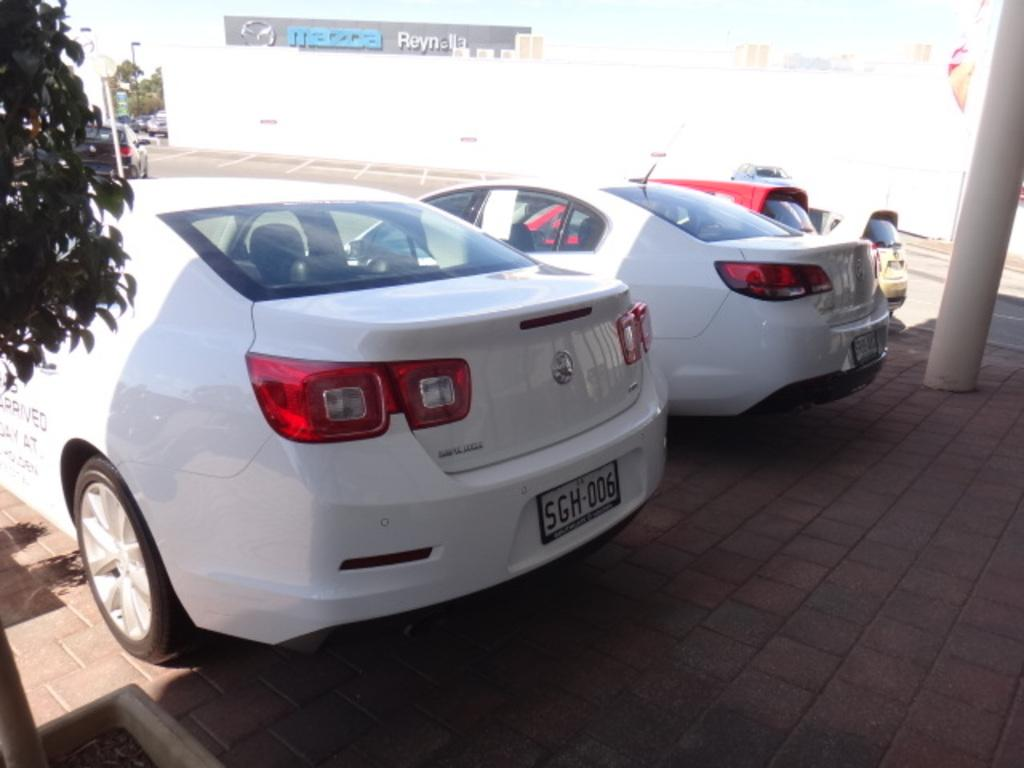<image>
Create a compact narrative representing the image presented. White car with a license plate which says SGH006. 